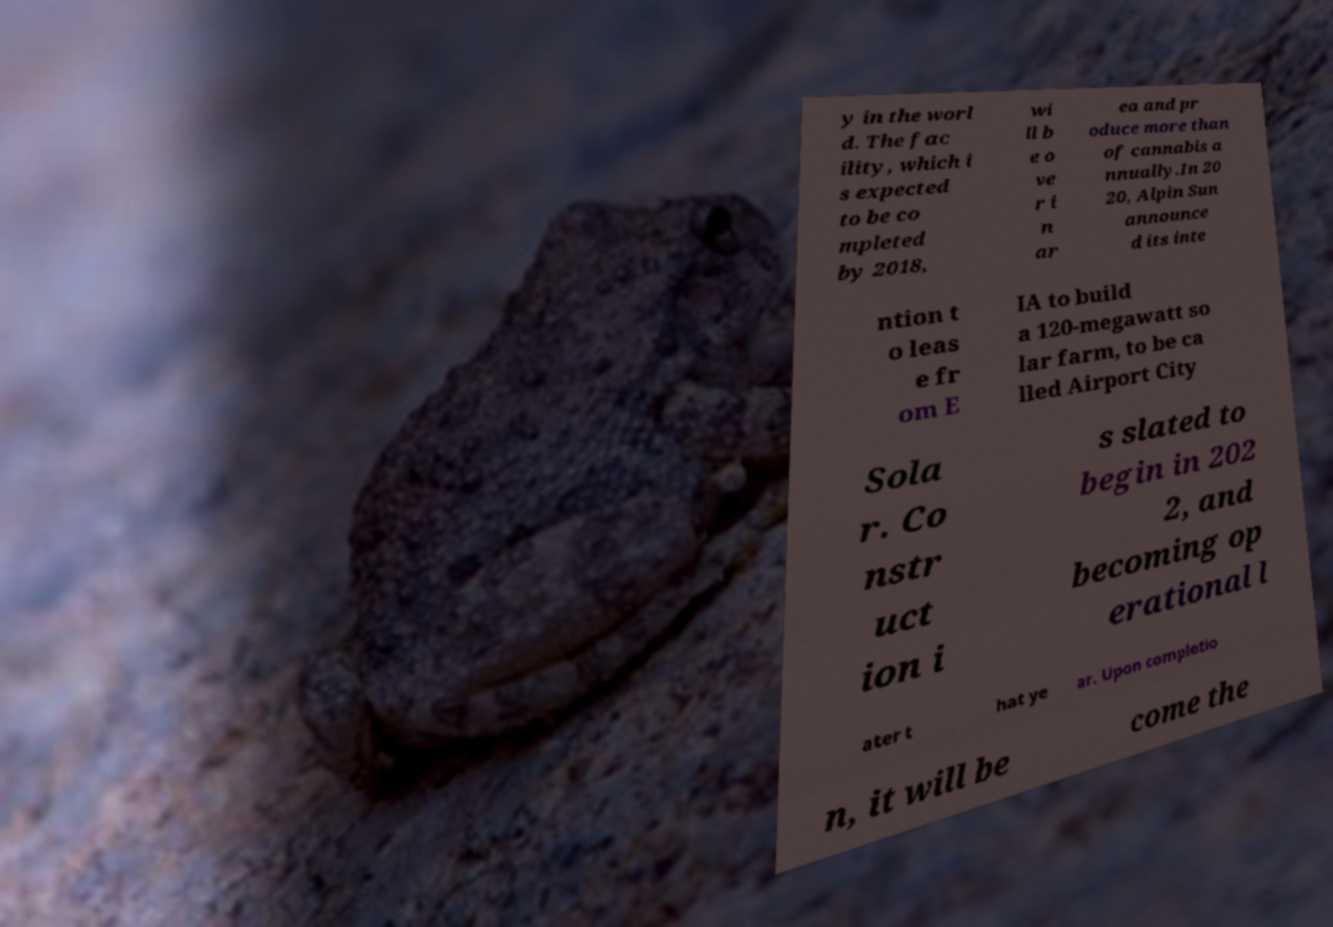There's text embedded in this image that I need extracted. Can you transcribe it verbatim? y in the worl d. The fac ility, which i s expected to be co mpleted by 2018, wi ll b e o ve r i n ar ea and pr oduce more than of cannabis a nnually.In 20 20, Alpin Sun announce d its inte ntion t o leas e fr om E IA to build a 120-megawatt so lar farm, to be ca lled Airport City Sola r. Co nstr uct ion i s slated to begin in 202 2, and becoming op erational l ater t hat ye ar. Upon completio n, it will be come the 